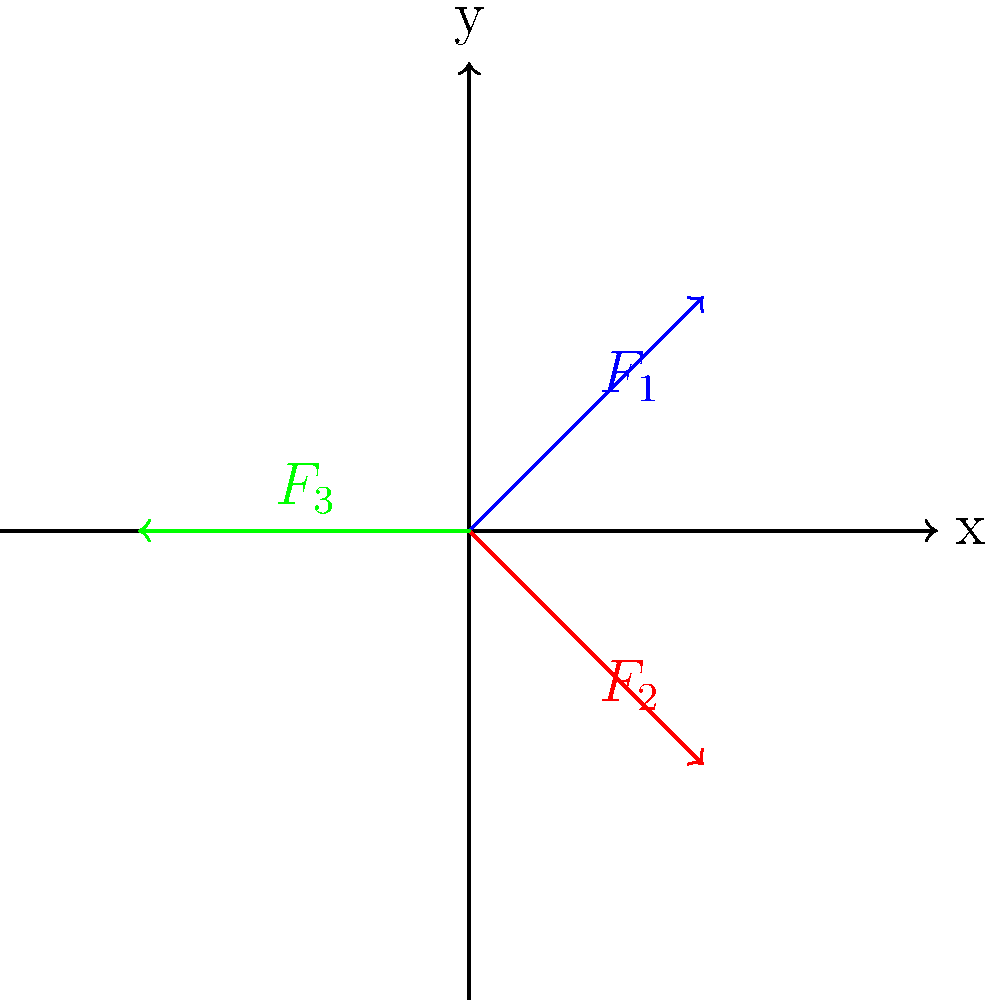In a project management scenario, you're tasked with optimizing the force distribution in a suspended platform system. The platform is in equilibrium under the influence of three forces: $F_1$ at 45° to the positive x-axis, $F_2$ at 45° to the negative x-axis, and $F_3$ acting horizontally to the left. If the magnitude of $F_1$ is 100 N and $F_2$ is 100 N, calculate the magnitude and direction of $F_3$ to maintain equilibrium. How might understanding this force balance improve workflow efficiency in similar engineering projects? Let's approach this step-by-step:

1) First, we need to break down $F_1$ and $F_2$ into their x and y components:

   $F_{1x} = F_1 \cos(45°) = 100 \cdot \frac{\sqrt{2}}{2} = 70.71$ N
   $F_{1y} = F_1 \sin(45°) = 100 \cdot \frac{\sqrt{2}}{2} = 70.71$ N

   $F_{2x} = F_2 \cos(45°) = 100 \cdot \frac{\sqrt{2}}{2} = 70.71$ N
   $F_{2y} = -F_2 \sin(45°) = -100 \cdot \frac{\sqrt{2}}{2} = -70.71$ N

2) For equilibrium, the sum of forces in both x and y directions must be zero:

   $\sum F_x = 0: F_{1x} + F_{2x} + F_3 = 0$
   $\sum F_y = 0: F_{1y} + F_{2y} = 0$

3) From the y-direction equation, we can see that $F_{1y}$ and $F_{2y}$ cancel out, confirming equilibrium in the y-direction.

4) For the x-direction:

   $70.71 + 70.71 + F_3 = 0$
   $141.42 + F_3 = 0$
   $F_3 = -141.42$ N

5) The negative sign indicates that $F_3$ acts in the negative x-direction (to the left), which matches the diagram.

6) The magnitude of $F_3$ is $|-141.42| = 141.42$ N.

7) The direction of $F_3$ is 180° from the positive x-axis (directly to the left).

Understanding this force balance can improve workflow efficiency in engineering projects by:
- Enabling quick assessments of structural stability
- Facilitating optimal resource allocation in design processes
- Enhancing decision-making in risk management scenarios
Answer: $F_3 = 141.42$ N, 180° from positive x-axis 